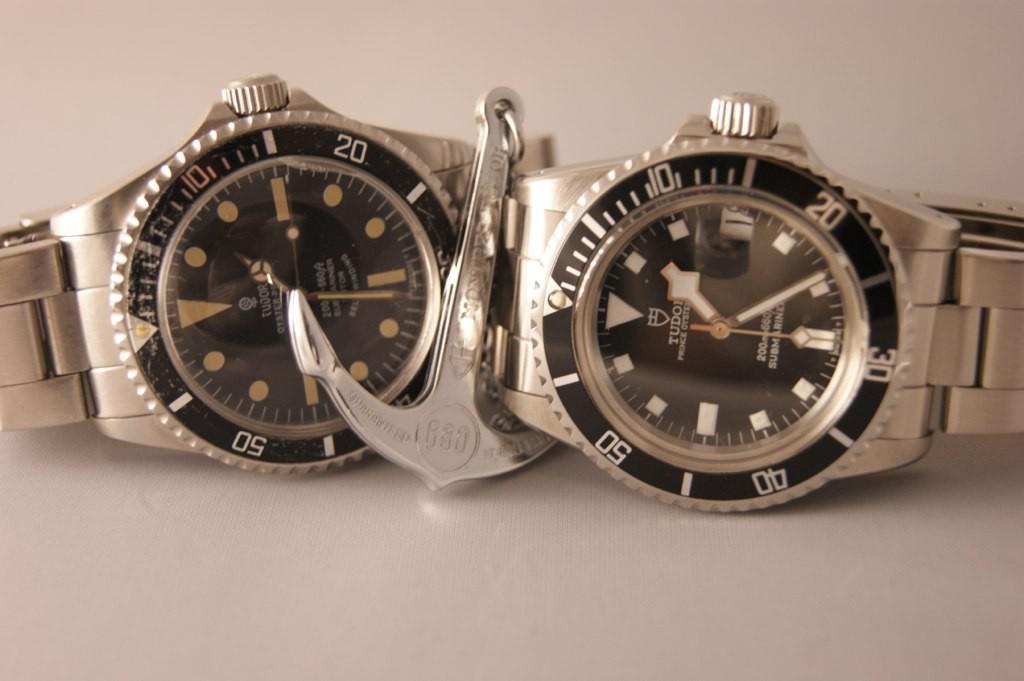What is the brand of watch?
Provide a succinct answer. Tudor. They are which product?
Ensure brevity in your answer.  Watch. 